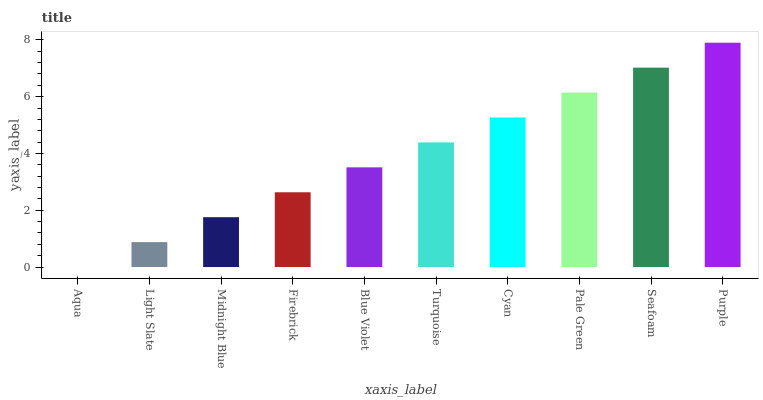Is Aqua the minimum?
Answer yes or no. Yes. Is Purple the maximum?
Answer yes or no. Yes. Is Light Slate the minimum?
Answer yes or no. No. Is Light Slate the maximum?
Answer yes or no. No. Is Light Slate greater than Aqua?
Answer yes or no. Yes. Is Aqua less than Light Slate?
Answer yes or no. Yes. Is Aqua greater than Light Slate?
Answer yes or no. No. Is Light Slate less than Aqua?
Answer yes or no. No. Is Turquoise the high median?
Answer yes or no. Yes. Is Blue Violet the low median?
Answer yes or no. Yes. Is Light Slate the high median?
Answer yes or no. No. Is Turquoise the low median?
Answer yes or no. No. 